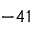<formula> <loc_0><loc_0><loc_500><loc_500>- 4 1</formula> 